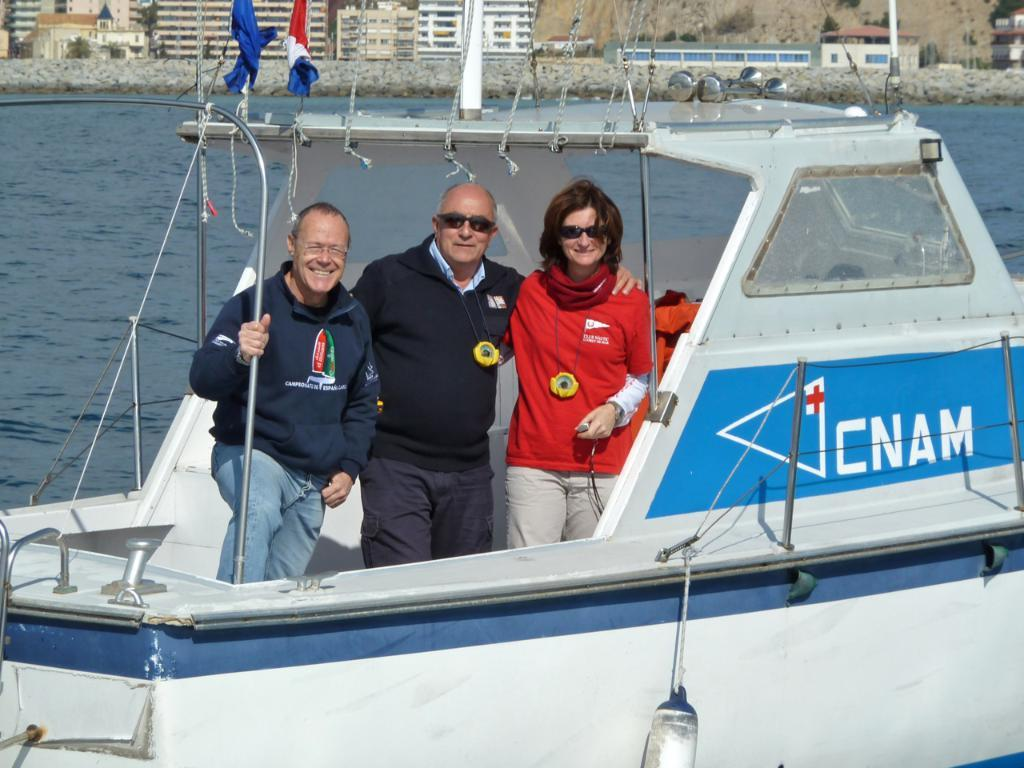Provide a one-sentence caption for the provided image. Three people are riding in a boat with CNAM on the side in white lettering. 